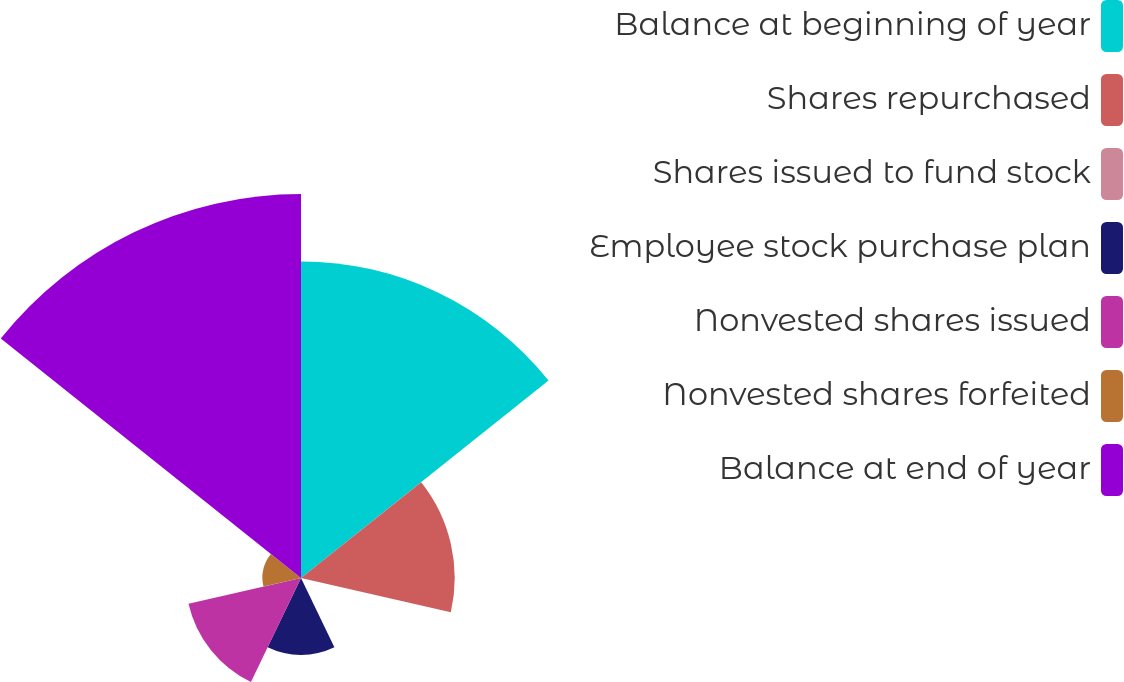Convert chart. <chart><loc_0><loc_0><loc_500><loc_500><pie_chart><fcel>Balance at beginning of year<fcel>Shares repurchased<fcel>Shares issued to fund stock<fcel>Employee stock purchase plan<fcel>Nonvested shares issued<fcel>Nonvested shares forfeited<fcel>Balance at end of year<nl><fcel>29.17%<fcel>14.16%<fcel>0.02%<fcel>7.09%<fcel>10.63%<fcel>3.55%<fcel>35.38%<nl></chart> 